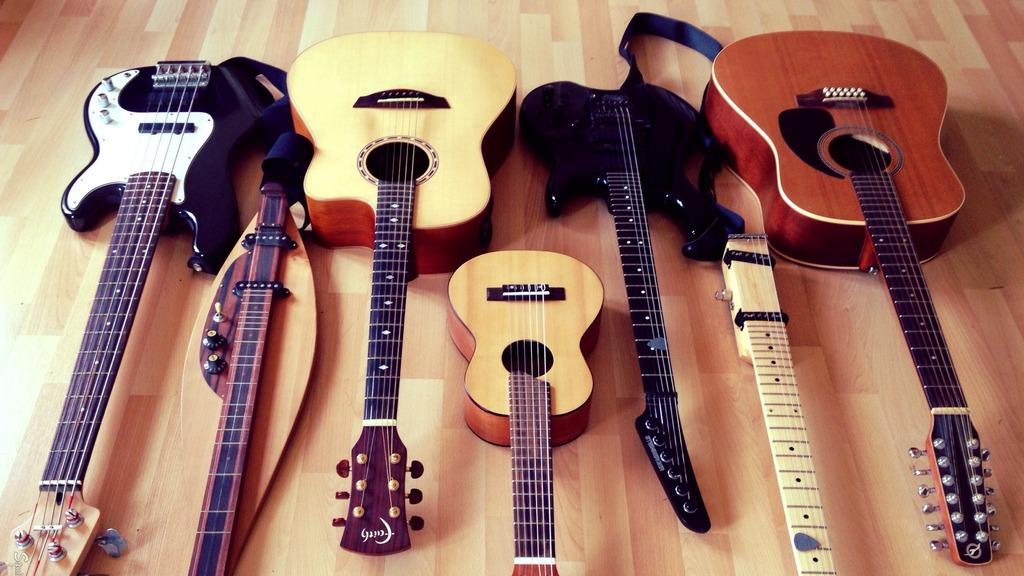How would you summarize this image in a sentence or two? There are group of musical instruments which is on the floor is shown in this image. 